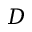<formula> <loc_0><loc_0><loc_500><loc_500>D</formula> 